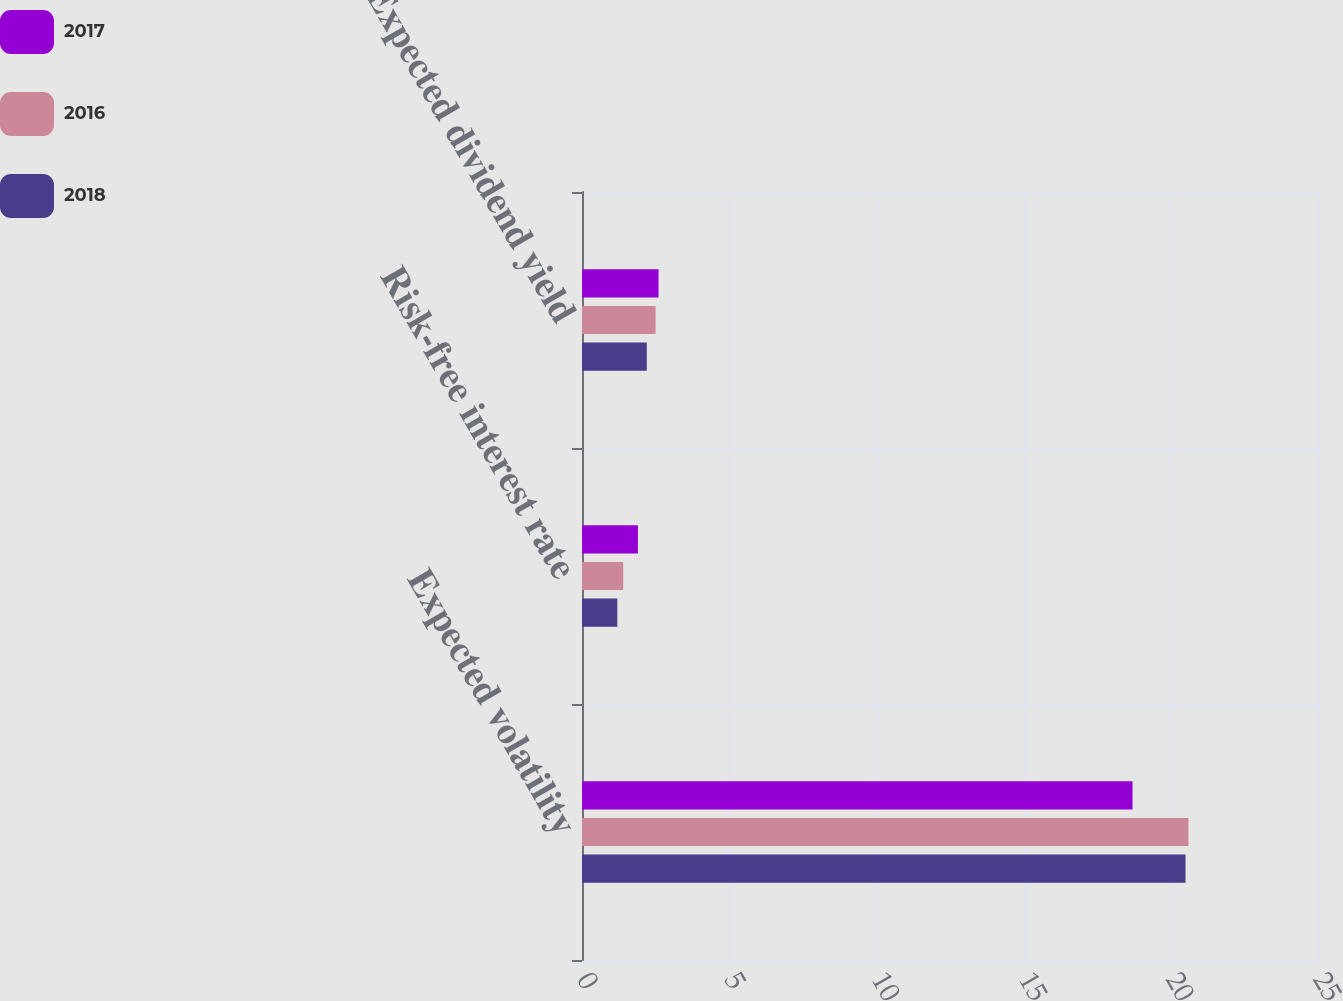Convert chart to OTSL. <chart><loc_0><loc_0><loc_500><loc_500><stacked_bar_chart><ecel><fcel>Expected volatility<fcel>Risk-free interest rate<fcel>Expected dividend yield<nl><fcel>2017<fcel>18.7<fcel>1.9<fcel>2.6<nl><fcel>2016<fcel>20.6<fcel>1.4<fcel>2.5<nl><fcel>2018<fcel>20.5<fcel>1.2<fcel>2.2<nl></chart> 